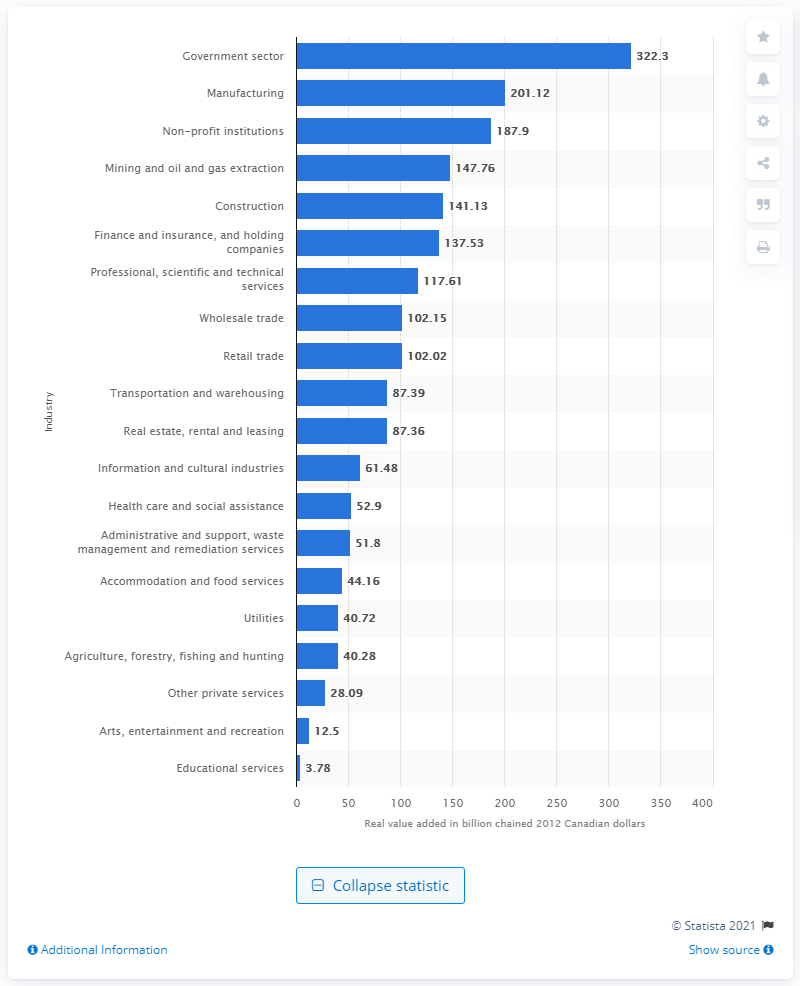Mention a couple of crucial points in this snapshot. The manufacturing industry contributed significantly to the Canadian GDP in 2019, with a total value added of 201.12. 